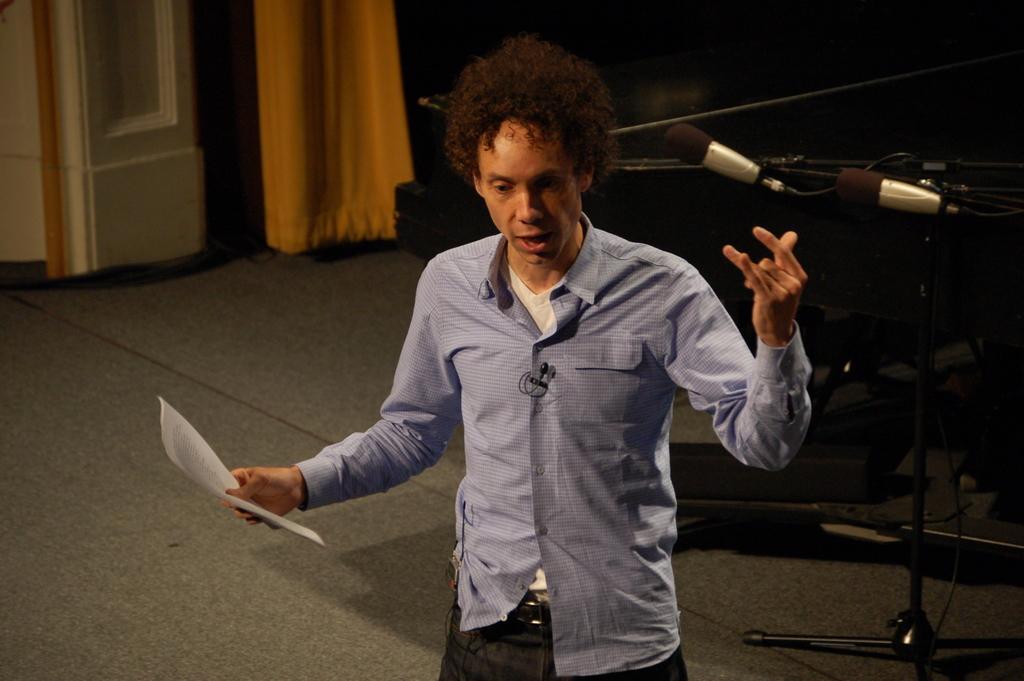Please provide a concise description of this image. In this image we can see a person holding a paper, there is a mic beside the person and there is a curtain and a white color object looks like a pillar in the background. 